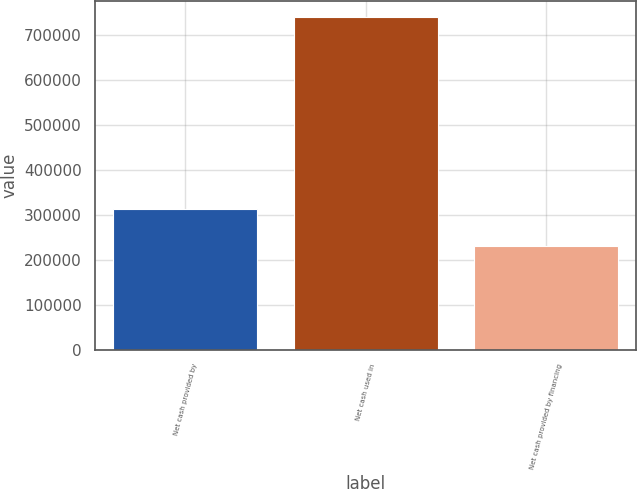Convert chart to OTSL. <chart><loc_0><loc_0><loc_500><loc_500><bar_chart><fcel>Net cash provided by<fcel>Net cash used in<fcel>Net cash provided by financing<nl><fcel>312860<fcel>739597<fcel>232099<nl></chart> 